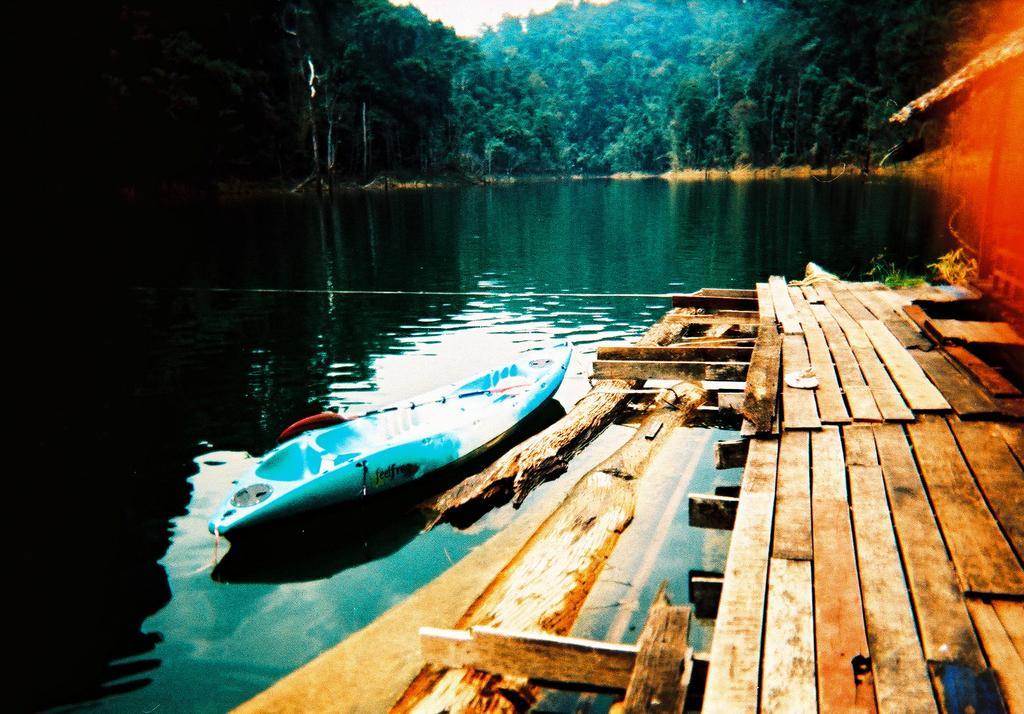How would you summarize this image in a sentence or two? In this image I can see the wooden surface. To the side I can see the boat which is in white and blue color. In the background I can see many trees and the sky. 